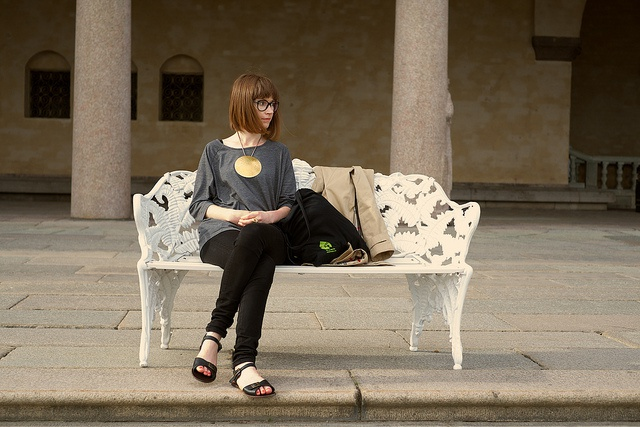Describe the objects in this image and their specific colors. I can see people in black, gray, maroon, and darkgray tones, bench in black, beige, darkgray, lightgray, and gray tones, and handbag in black, darkgreen, gray, and tan tones in this image. 